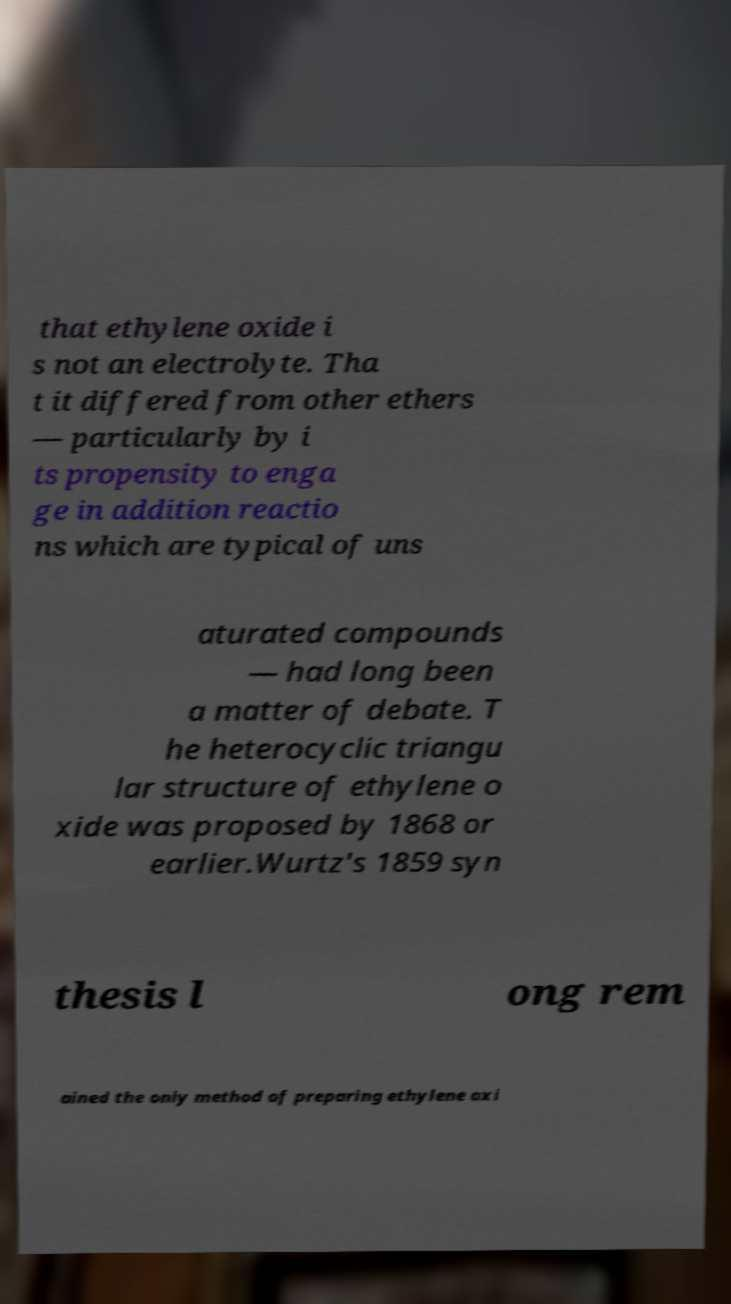There's text embedded in this image that I need extracted. Can you transcribe it verbatim? that ethylene oxide i s not an electrolyte. Tha t it differed from other ethers — particularly by i ts propensity to enga ge in addition reactio ns which are typical of uns aturated compounds — had long been a matter of debate. T he heterocyclic triangu lar structure of ethylene o xide was proposed by 1868 or earlier.Wurtz's 1859 syn thesis l ong rem ained the only method of preparing ethylene oxi 